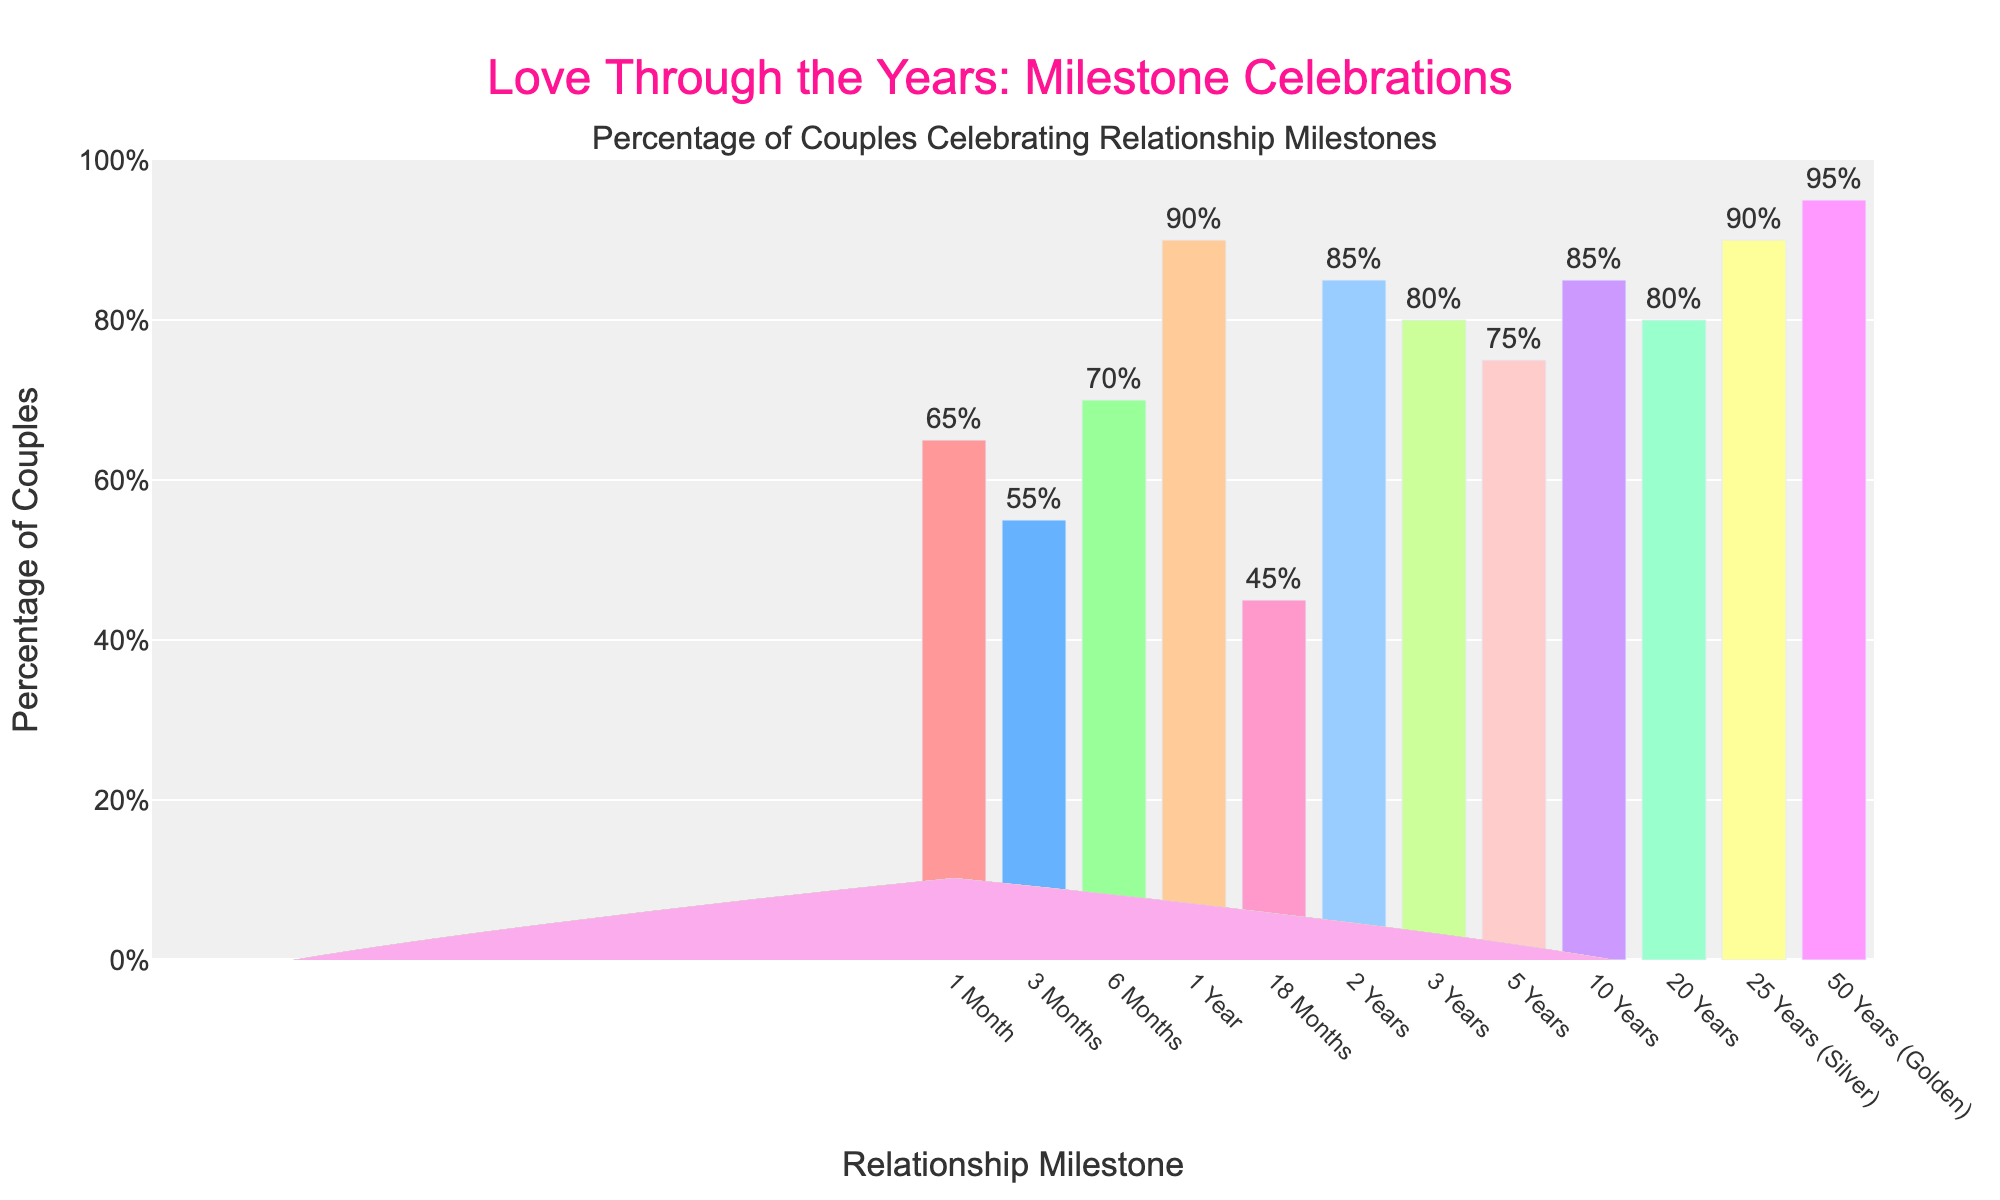Which milestone has the highest percentage of couples celebrating it? The bar chart shows the percentages of couples celebrating various relationship milestones. The tallest bar represents the highest percentage. In this case, the "50 Years (Golden)" milestone has the tallest bar at 95%.
Answer: 50 Years (Golden) How many years together correspond to the first milestone where more than 80% of couples celebrate? Observing the bars, the first milestone with a percentage greater than 80% is "1 Year" with 90%.
Answer: 1 Year Which milestones have exactly the same percentage of couples celebrating them? Examining the chart closely, the "2 Years" and "10 Years" milestones both have 85%, and "3 Years" and "20 Years" both have 80%.
Answer: 2 Years and 10 Years; 3 Years and 20 Years What is the difference in the percentage of couples celebrating 3 months versus 3 years? From the chart, the "3 Months" milestone has 55% and the "3 Years" milestone has 80%. The difference in percentage is calculated by subtracting these values: 80% - 55% = 25%.
Answer: 25% What is the average percentage of couples celebrating anniversaries of less than 2 years? The anniversaries of less than 2 years are "1 Month" (65%), "3 Months" (55%), "6 Months" (70%), and "1 Year" (90%). The sum is 65 + 55 + 70 + 90 = 280. There are 4 milestones, so the average is 280/4 = 70%.
Answer: 70% Among the milestones listed, which has the lowest percentage of couples celebrating, and what is that percentage? The chart shows "18 Months" being the milestone with the shortest bar, indicating the lowest percentage at 45%.
Answer: 18 Months, 45% Is there a milestone with a percentage of celebrating couples falling precisely at the midpoint of two other milestones? By checking the percentages, the "6 Months" milestone has 70%, which is exactly midway between "3 Months" at 55% and "1 Year" at 90% (since (55 + 90) / 2 = 72.5, and 70 is the closest milestone to this midpoint).
Answer: 6 Months, 70% What's the combined percentage of couples celebrating "25 Years (Silver)" and "50 Years (Golden)" milestones? The chart shows "25 Years (Silver)" at 90% and "50 Years (Golden)" at 95%. The combined percentage is 90 + 95 = 185%.
Answer: 185% What percentage of couples celebrate anniversaries after 5 years together? The milestones for anniversaries after 5 years are "10 Years" (85%), "20 Years" (80%), "25 Years (Silver)" (90%), and "50 Years (Golden)" (95%). Adding these percentages gives 85 + 80 + 90 + 95 = 350%.
Answer: 350% Are there more couples celebrating their "1 Month" versus "5 Years" milestone? Comparing the "1 Month" milestone at 65% and the "5 Years" milestone at 75%, there are more couples celebrating their "5 Years" milestone.
Answer: No 